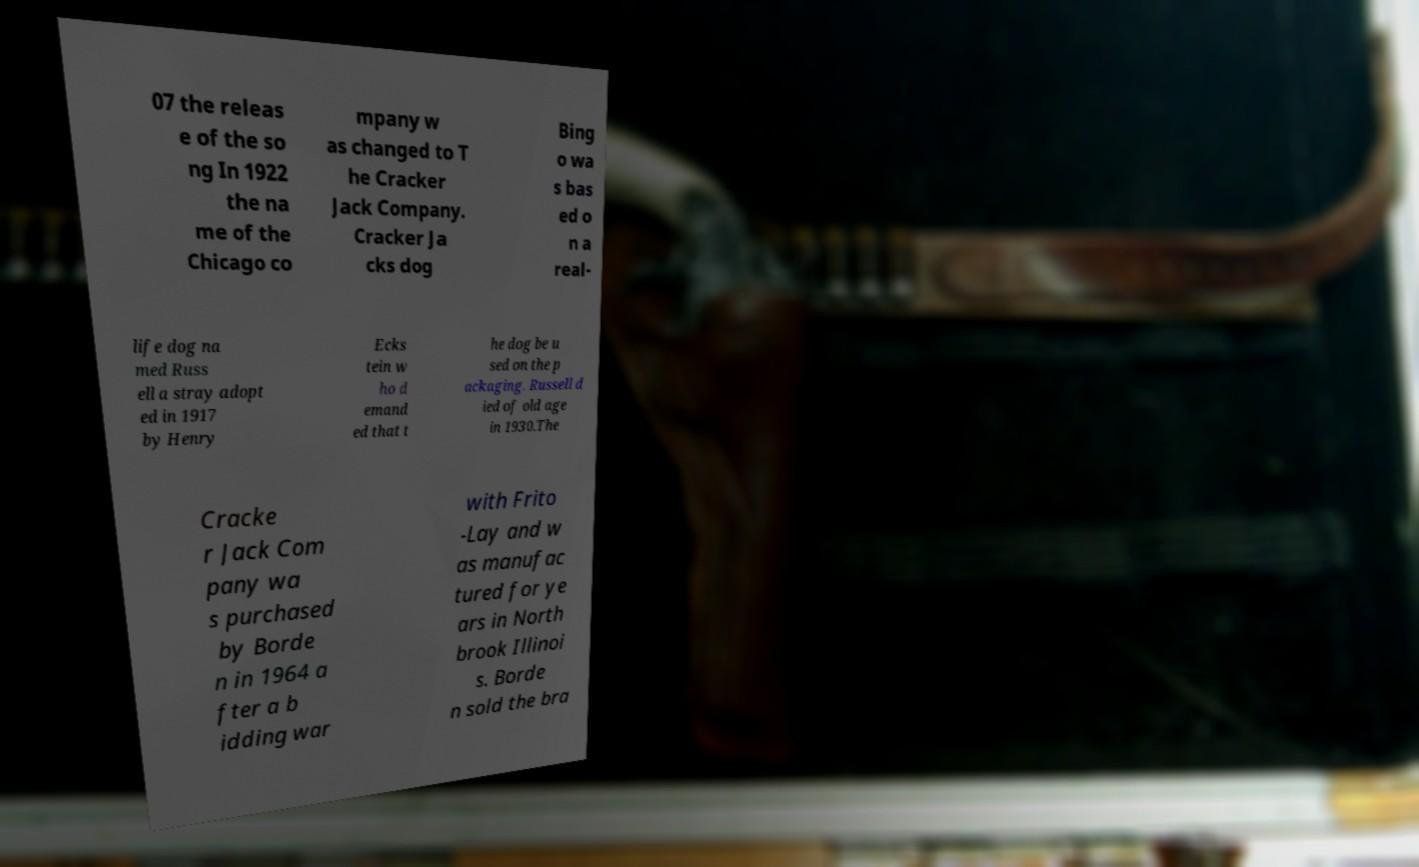Could you extract and type out the text from this image? 07 the releas e of the so ng In 1922 the na me of the Chicago co mpany w as changed to T he Cracker Jack Company. Cracker Ja cks dog Bing o wa s bas ed o n a real- life dog na med Russ ell a stray adopt ed in 1917 by Henry Ecks tein w ho d emand ed that t he dog be u sed on the p ackaging. Russell d ied of old age in 1930.The Cracke r Jack Com pany wa s purchased by Borde n in 1964 a fter a b idding war with Frito -Lay and w as manufac tured for ye ars in North brook Illinoi s. Borde n sold the bra 